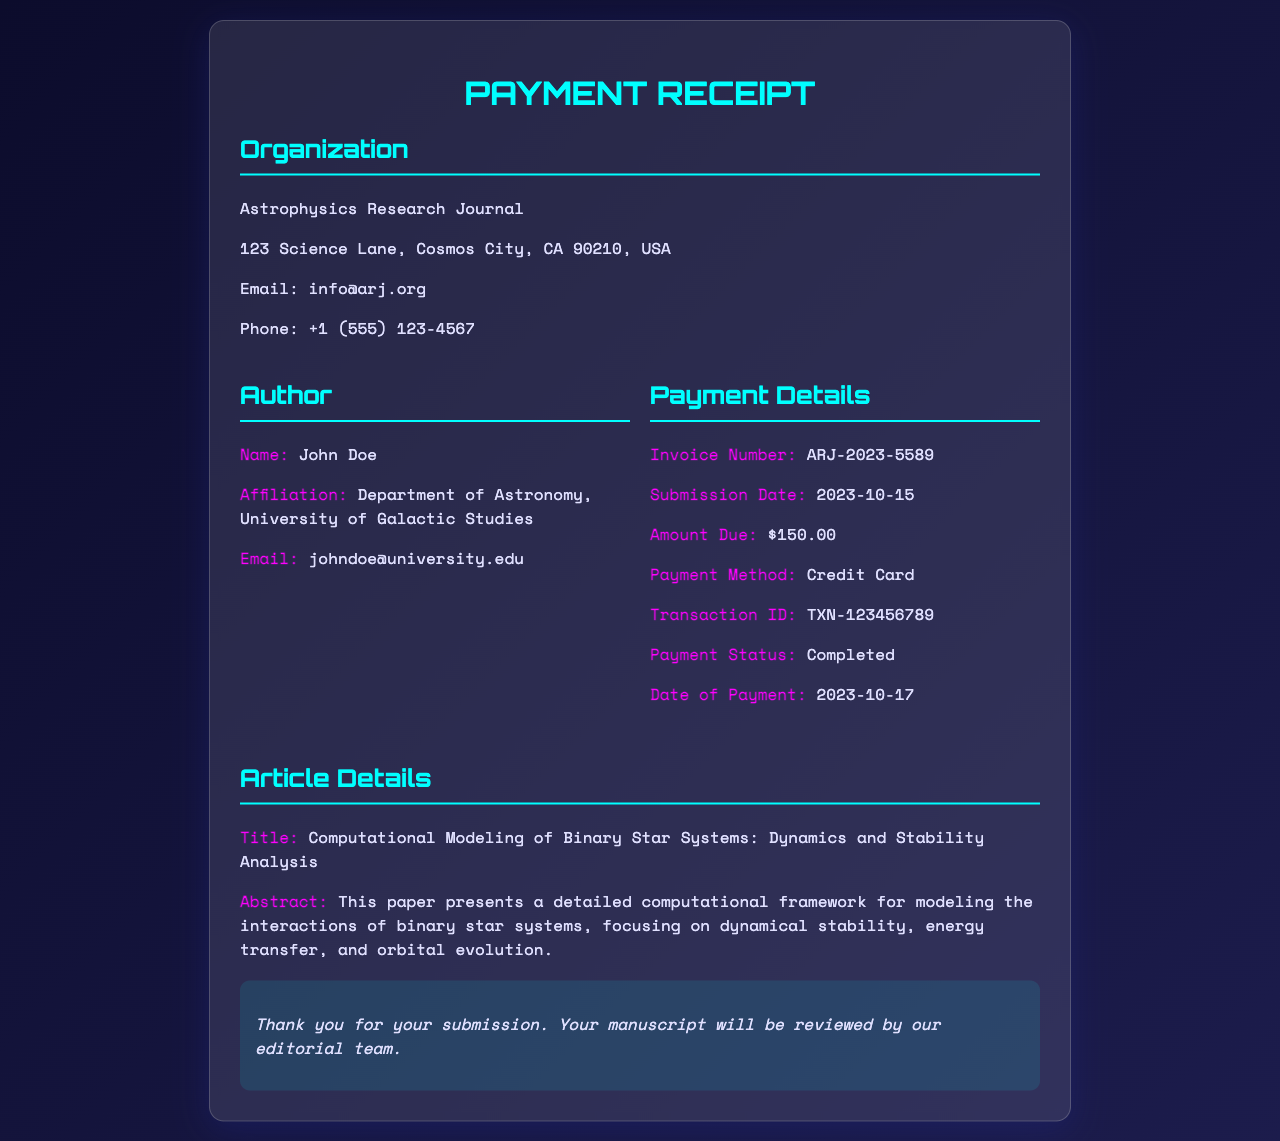What is the invoice number? The invoice number is listed in the payment details of the receipt.
Answer: ARJ-2023-5589 What is the submission date? The submission date is found in the payment details section of the receipt.
Answer: 2023-10-15 What is the total amount due? The amount due is specified under payment details in the document.
Answer: $150.00 What is the transaction ID? The transaction ID is provided in the payment details section of the receipt.
Answer: TXN-123456789 What is the payment status? The payment status indicates whether the payment has been completed or not, found in the payment details.
Answer: Completed What is the title of the article? The title is stated in the article details section of the receipt.
Answer: Computational Modeling of Binary Star Systems: Dynamics and Stability Analysis How many days passed from submission to payment? The difference between the submission date and payment date gives the number of days.
Answer: 2 days What is the author's affiliation? The author's affiliation is included in the author details section of the receipt.
Answer: Department of Astronomy, University of Galactic Studies What is the email address of the author? The author's email is indicated in the author details of the receipt.
Answer: johndoe@university.edu 